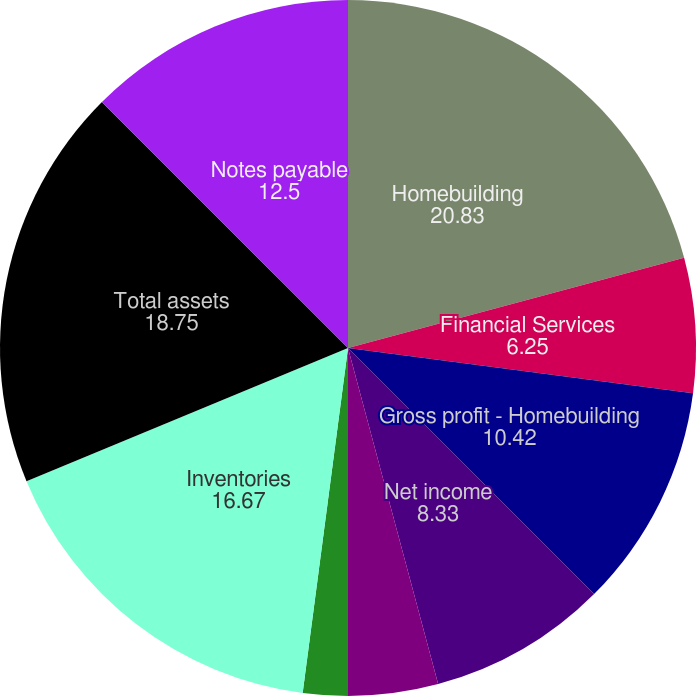Convert chart. <chart><loc_0><loc_0><loc_500><loc_500><pie_chart><fcel>Homebuilding<fcel>Financial Services<fcel>Gross profit - Homebuilding<fcel>Net income<fcel>Basic<fcel>Diluted (3)<fcel>Cash dividends declared per<fcel>Inventories<fcel>Total assets<fcel>Notes payable<nl><fcel>20.83%<fcel>6.25%<fcel>10.42%<fcel>8.33%<fcel>4.17%<fcel>2.08%<fcel>0.0%<fcel>16.67%<fcel>18.75%<fcel>12.5%<nl></chart> 